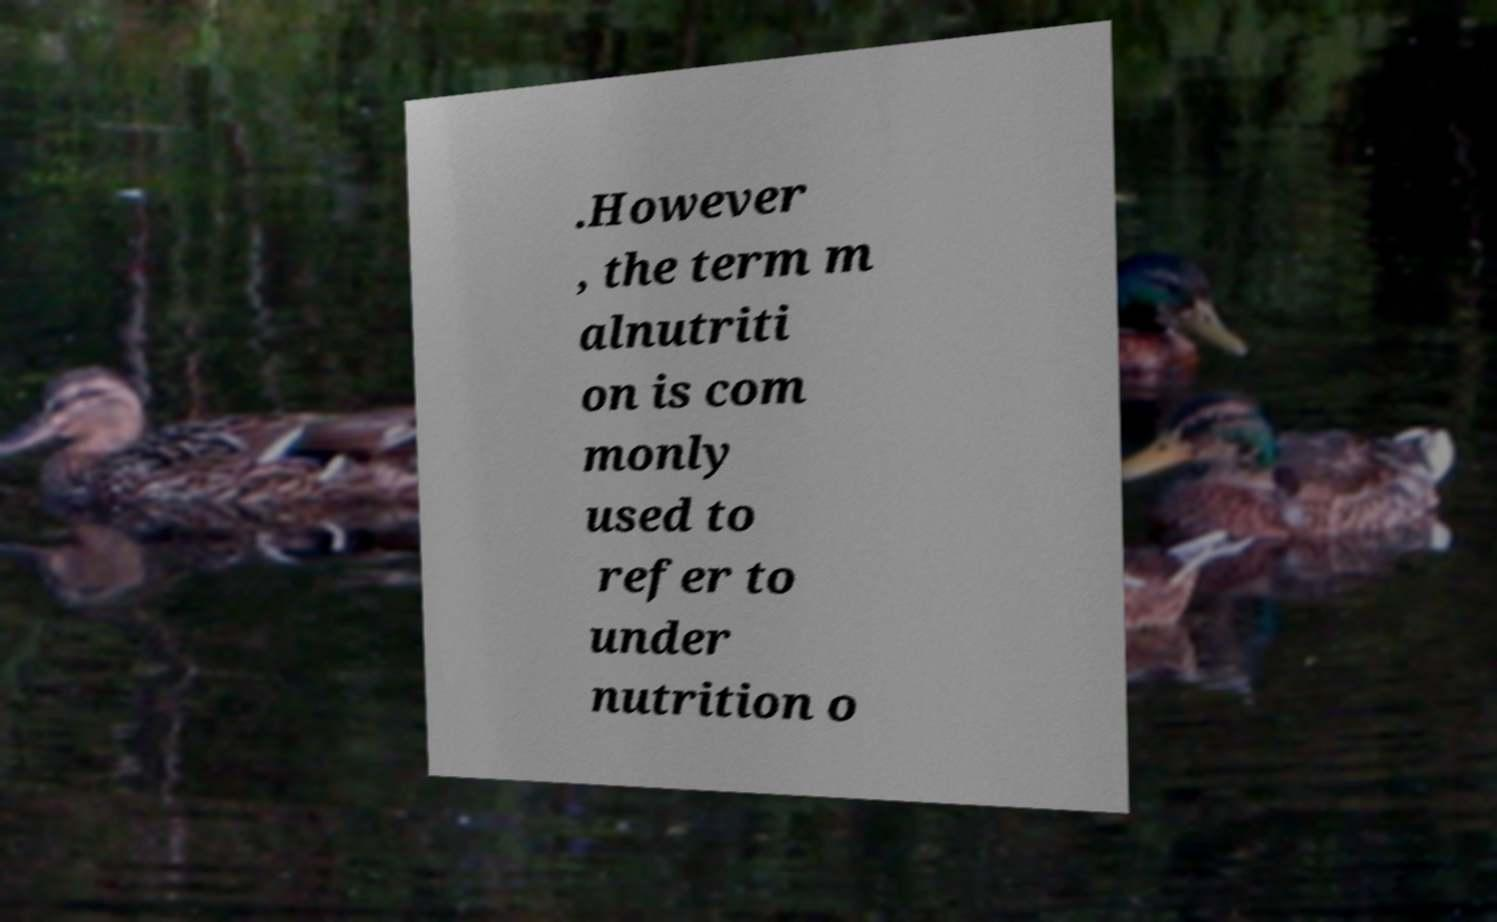For documentation purposes, I need the text within this image transcribed. Could you provide that? .However , the term m alnutriti on is com monly used to refer to under nutrition o 